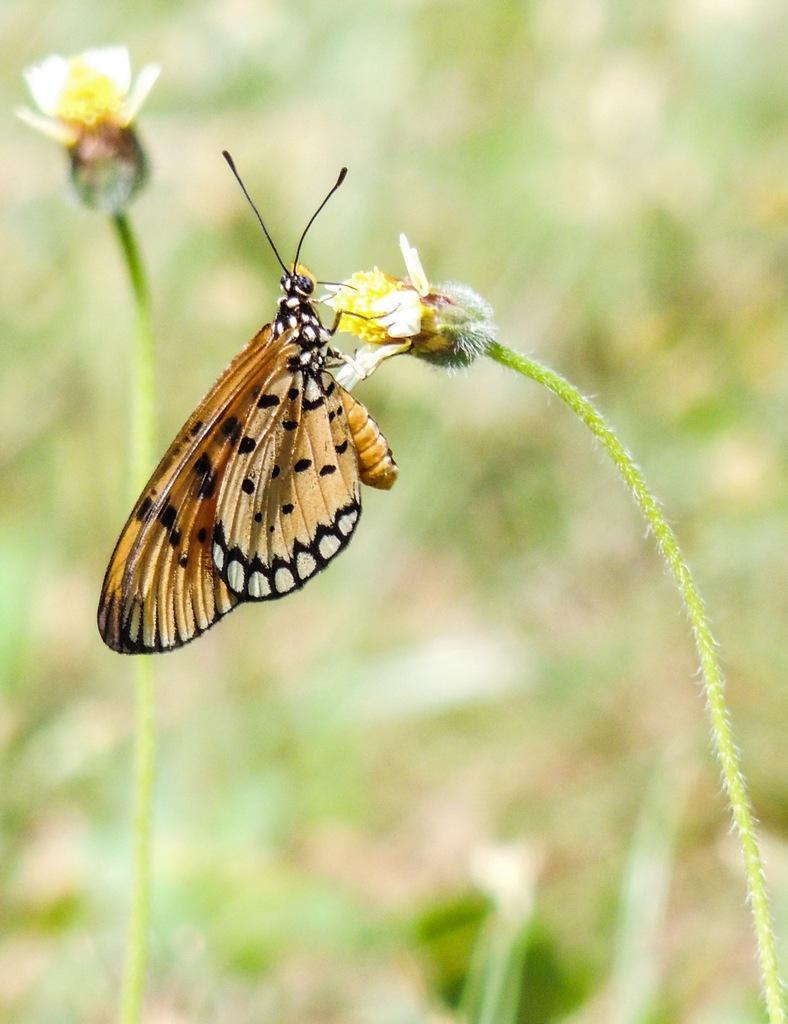In one or two sentences, can you explain what this image depicts? In this image I can see a butterfly which is orange, black and white in color is on a flower which is white, yellow and green in color to a plant which is green in color. I can see the blurry background which is green in color and a flower. 